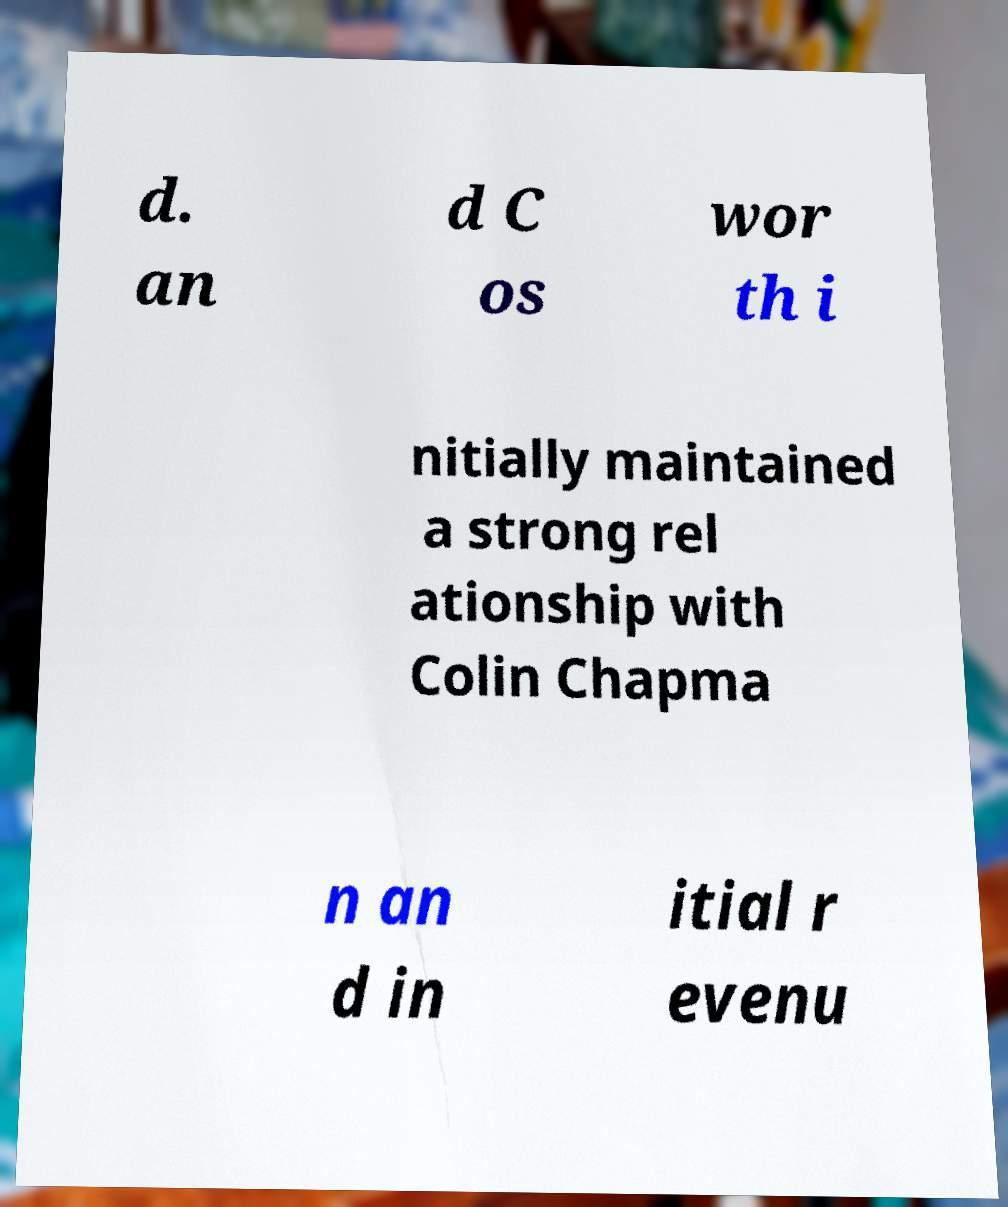Can you read and provide the text displayed in the image?This photo seems to have some interesting text. Can you extract and type it out for me? d. an d C os wor th i nitially maintained a strong rel ationship with Colin Chapma n an d in itial r evenu 